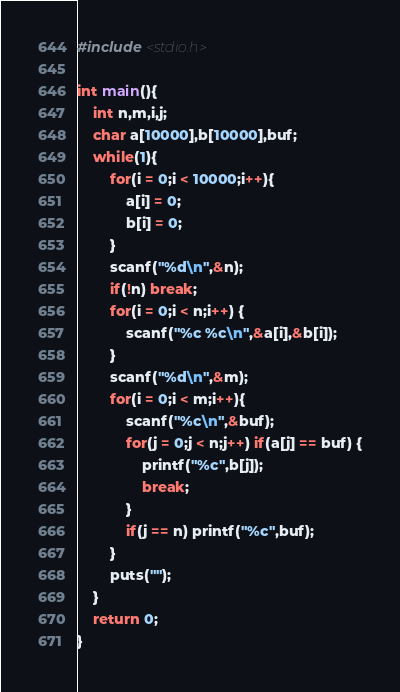Convert code to text. <code><loc_0><loc_0><loc_500><loc_500><_C_>#include <stdio.h>

int main(){
	int n,m,i,j;
	char a[10000],b[10000],buf;
	while(1){
		for(i = 0;i < 10000;i++){
			a[i] = 0;
			b[i] = 0;
		}
		scanf("%d\n",&n);
		if(!n) break;
		for(i = 0;i < n;i++) {
			scanf("%c %c\n",&a[i],&b[i]);
		}
		scanf("%d\n",&m);
		for(i = 0;i < m;i++){
			scanf("%c\n",&buf);
			for(j = 0;j < n;j++) if(a[j] == buf) {
				printf("%c",b[j]);
				break;
			}
			if(j == n) printf("%c",buf);
		}
		puts("");
	}
	return 0;
}</code> 